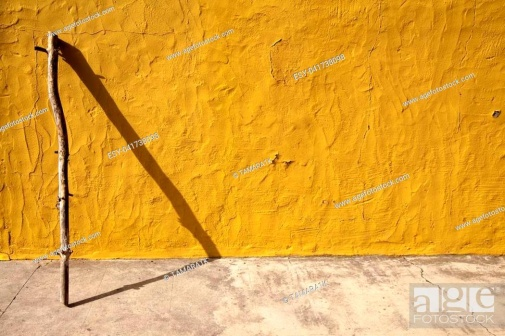Imagine this setting in a different season. How would it change? If this scene were captured in a different season, such as winter, the yellow wall might be slightly weathered by frost, with minimal snowdrifts along the ground's edge. The stick could be coated in a thin layer of ice, its shadow dark and crisp against the snowy background, producing a stark yet serene winter landscape. 